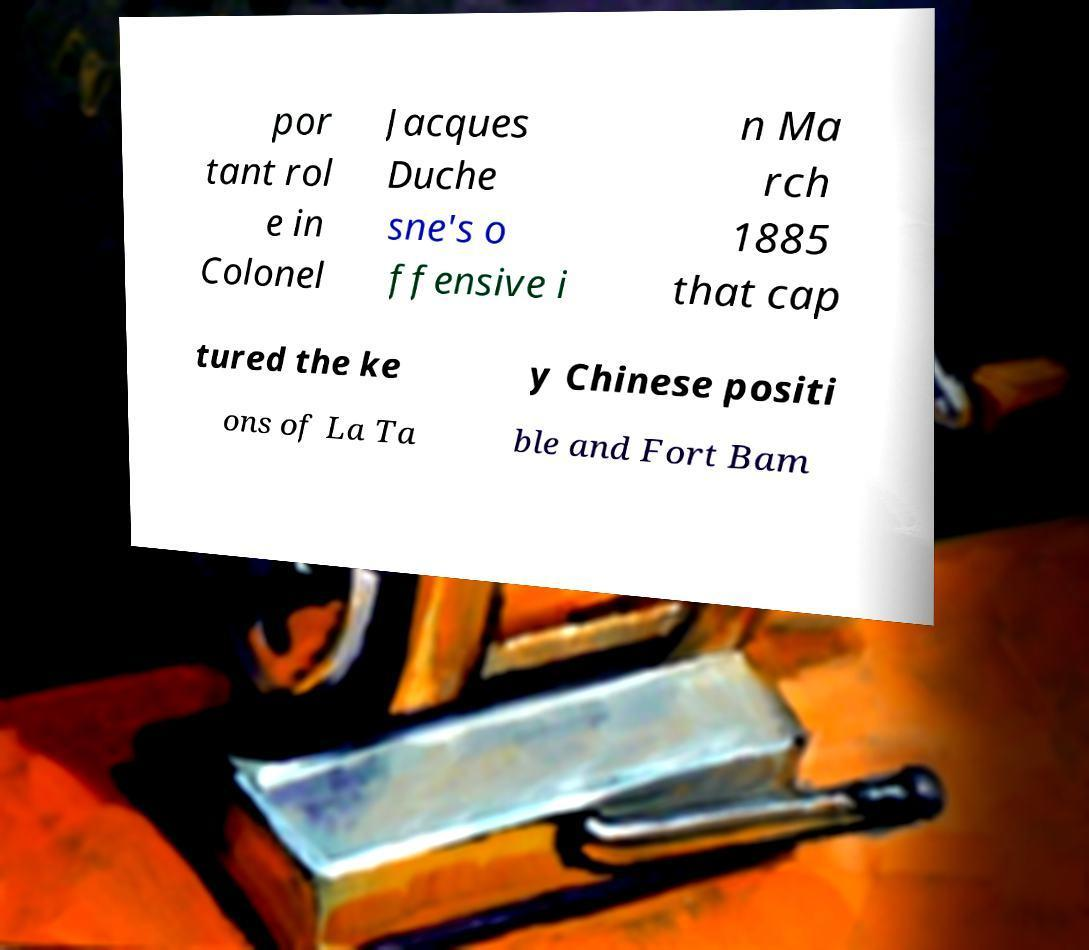There's text embedded in this image that I need extracted. Can you transcribe it verbatim? por tant rol e in Colonel Jacques Duche sne's o ffensive i n Ma rch 1885 that cap tured the ke y Chinese positi ons of La Ta ble and Fort Bam 